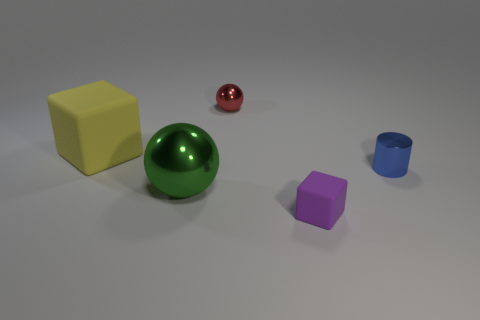Is there a red thing that has the same size as the purple object?
Give a very brief answer. Yes. There is a matte block that is in front of the big matte cube; how big is it?
Offer a terse response. Small. There is a tiny metallic thing in front of the rubber thing left of the cube that is in front of the tiny blue object; what is its color?
Ensure brevity in your answer.  Blue. There is a small metal object in front of the cube left of the green shiny sphere; what is its color?
Your response must be concise. Blue. Are there more green things to the left of the big sphere than metal cylinders that are to the right of the blue metal object?
Your response must be concise. No. Does the block that is behind the small purple rubber object have the same material as the sphere in front of the blue metal object?
Make the answer very short. No. There is a small purple thing; are there any big metallic balls left of it?
Provide a succinct answer. Yes. How many red objects are either tiny matte blocks or metal objects?
Your answer should be very brief. 1. Are the small blue object and the large thing that is behind the green ball made of the same material?
Your answer should be very brief. No. What is the size of the other thing that is the same shape as the small red thing?
Provide a short and direct response. Large. 